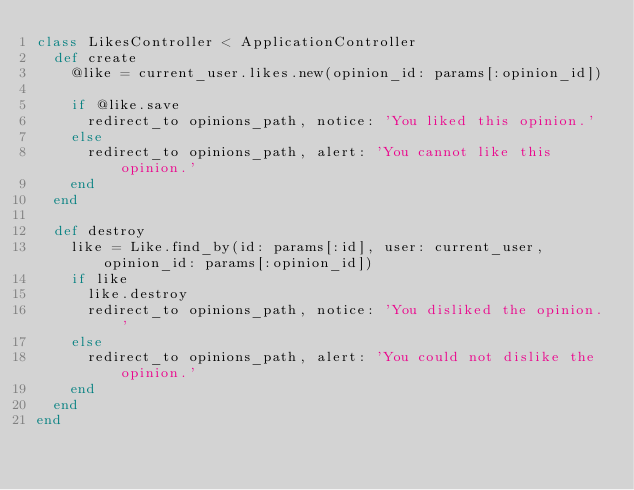Convert code to text. <code><loc_0><loc_0><loc_500><loc_500><_Ruby_>class LikesController < ApplicationController
  def create
    @like = current_user.likes.new(opinion_id: params[:opinion_id])

    if @like.save
      redirect_to opinions_path, notice: 'You liked this opinion.'
    else
      redirect_to opinions_path, alert: 'You cannot like this opinion.'
    end
  end

  def destroy
    like = Like.find_by(id: params[:id], user: current_user, opinion_id: params[:opinion_id])
    if like
      like.destroy
      redirect_to opinions_path, notice: 'You disliked the opinion.'
    else
      redirect_to opinions_path, alert: 'You could not dislike the opinion.'
    end
  end
end
</code> 